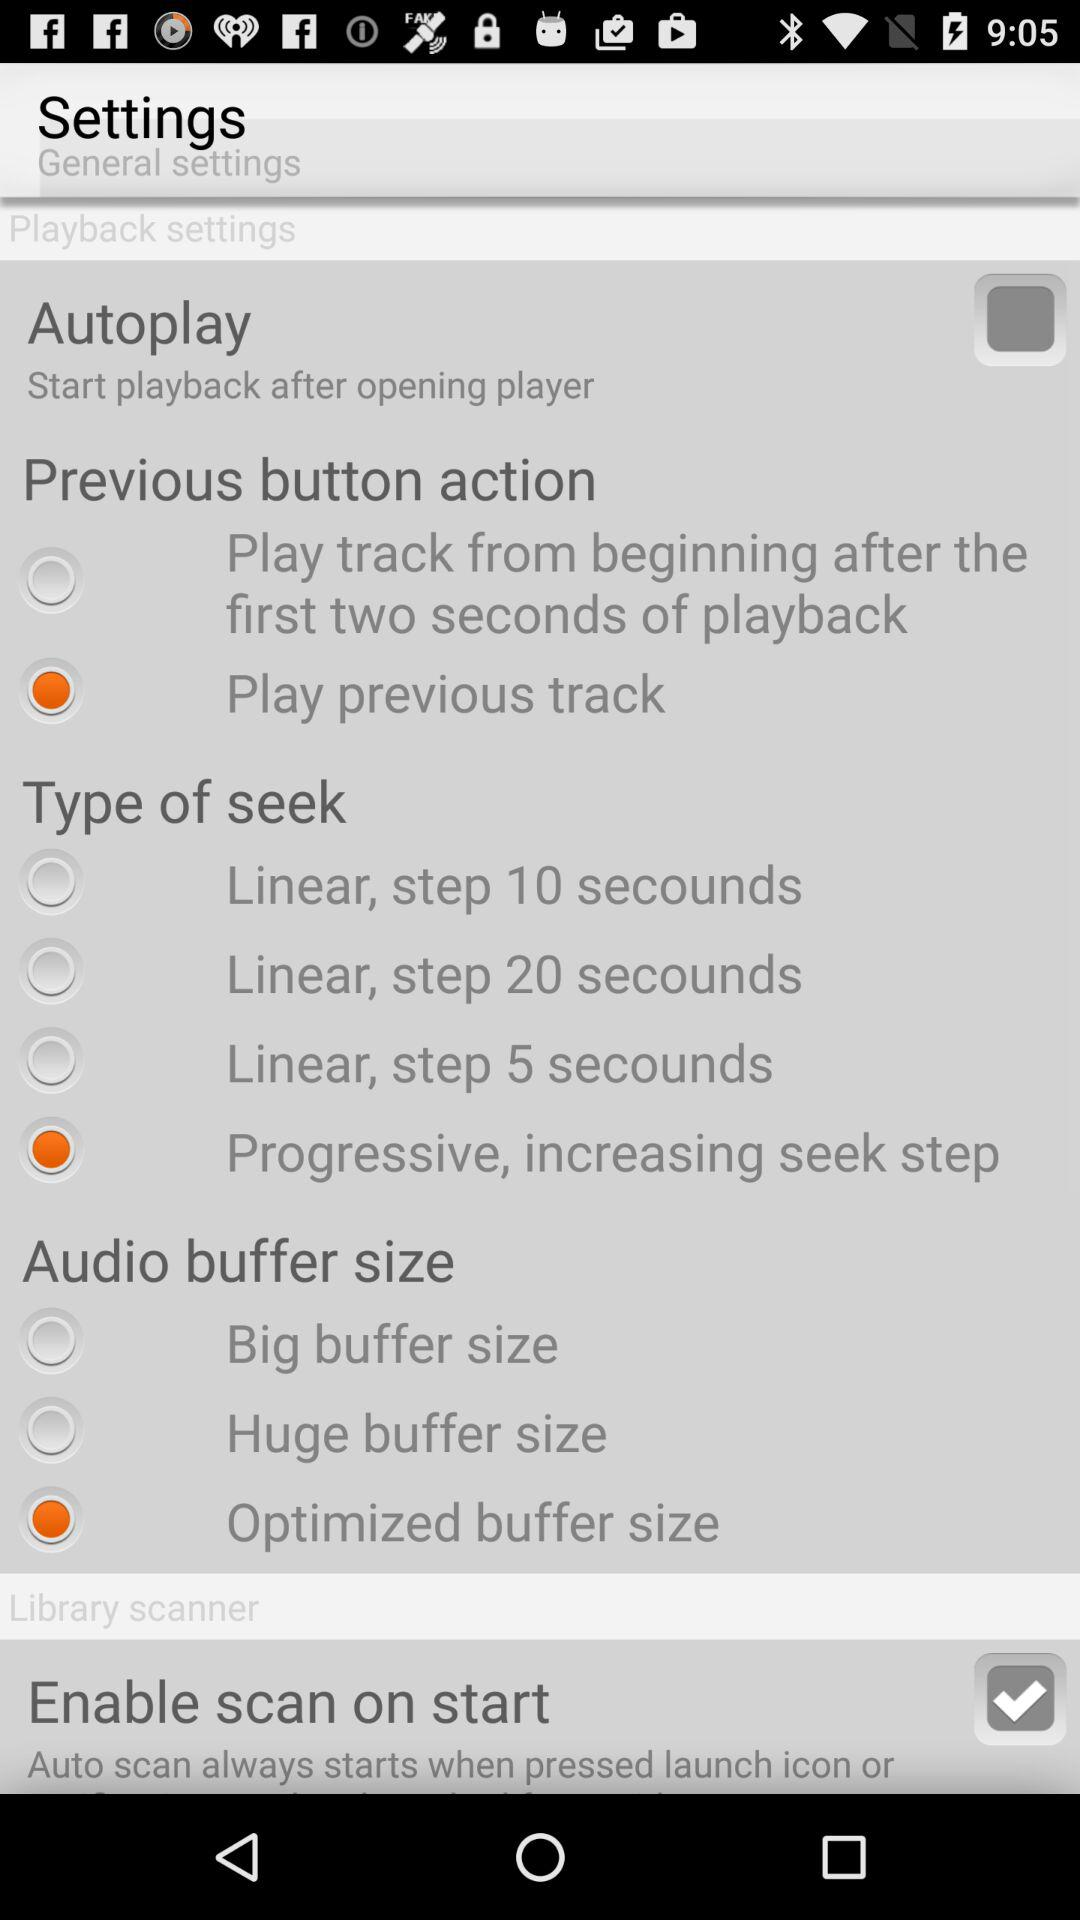What option is selected in "Type of seek"? The selected option is "Progressive, increasing seek step". 